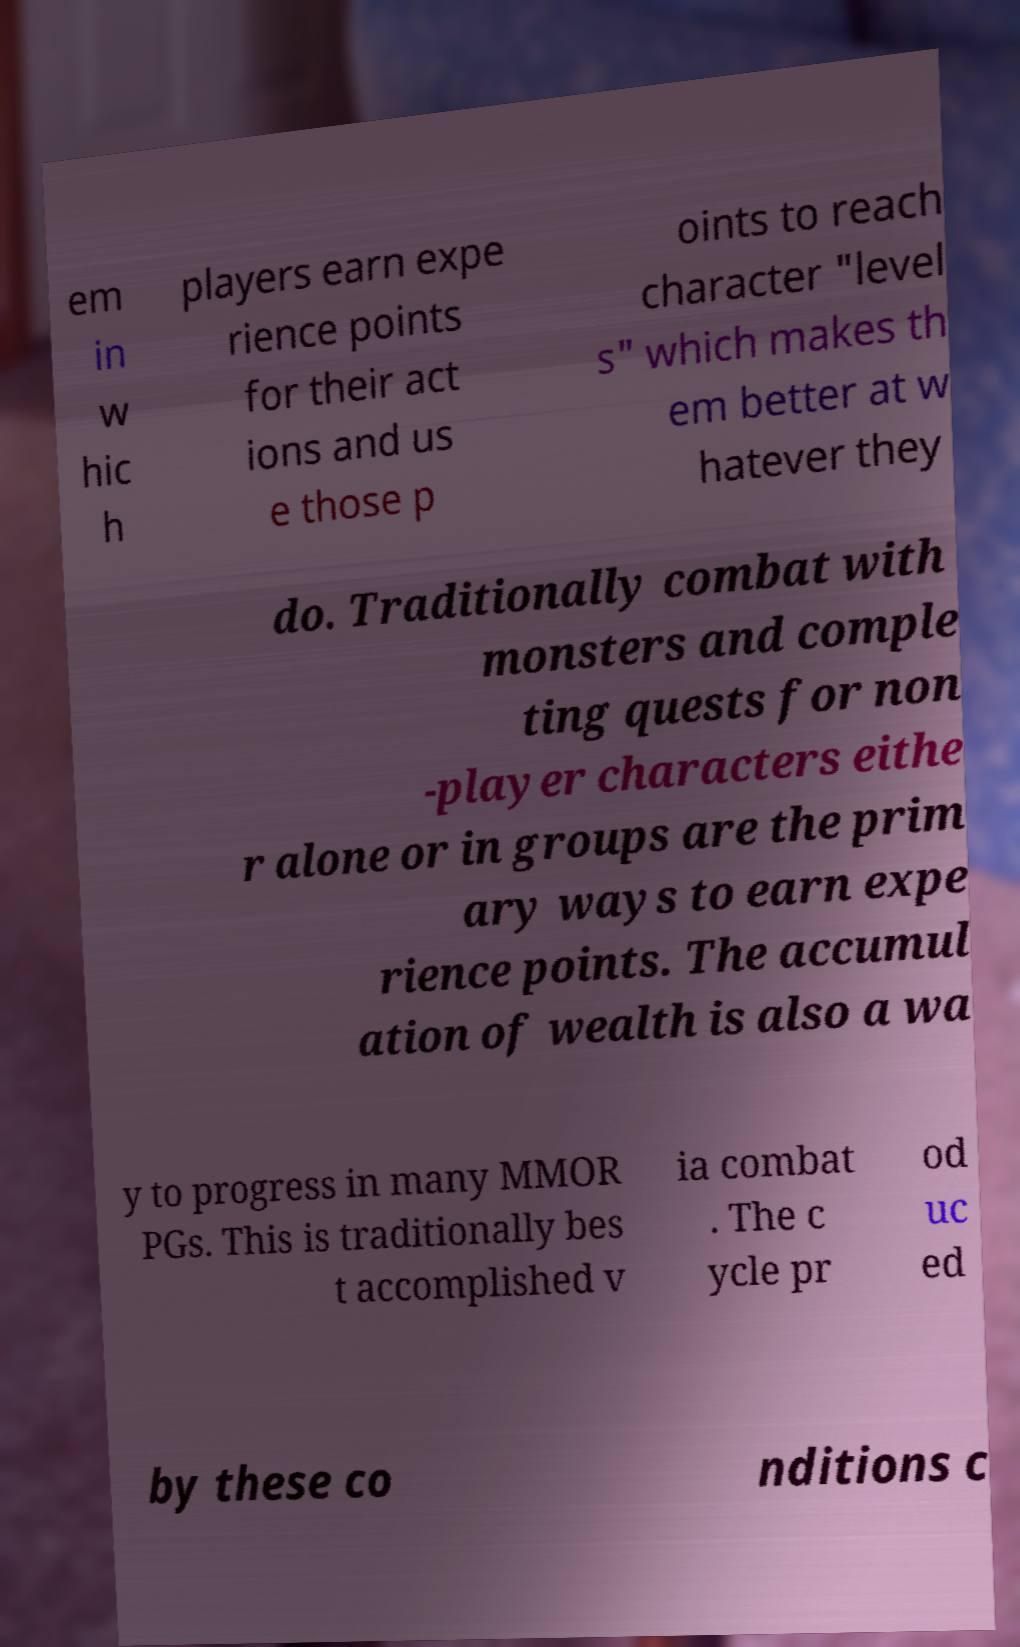Can you read and provide the text displayed in the image?This photo seems to have some interesting text. Can you extract and type it out for me? em in w hic h players earn expe rience points for their act ions and us e those p oints to reach character "level s" which makes th em better at w hatever they do. Traditionally combat with monsters and comple ting quests for non -player characters eithe r alone or in groups are the prim ary ways to earn expe rience points. The accumul ation of wealth is also a wa y to progress in many MMOR PGs. This is traditionally bes t accomplished v ia combat . The c ycle pr od uc ed by these co nditions c 